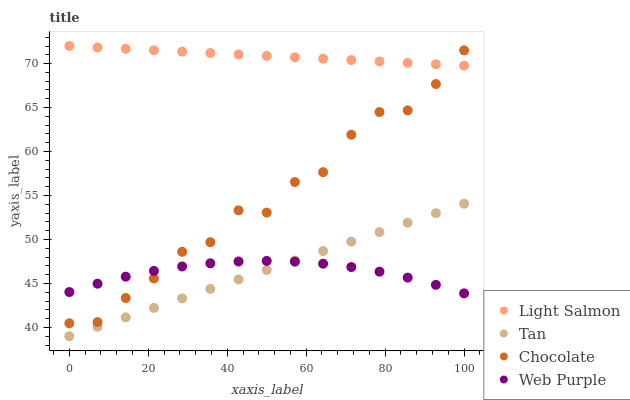Does Web Purple have the minimum area under the curve?
Answer yes or no. Yes. Does Light Salmon have the maximum area under the curve?
Answer yes or no. Yes. Does Tan have the minimum area under the curve?
Answer yes or no. No. Does Tan have the maximum area under the curve?
Answer yes or no. No. Is Tan the smoothest?
Answer yes or no. Yes. Is Chocolate the roughest?
Answer yes or no. Yes. Is Light Salmon the smoothest?
Answer yes or no. No. Is Light Salmon the roughest?
Answer yes or no. No. Does Tan have the lowest value?
Answer yes or no. Yes. Does Light Salmon have the lowest value?
Answer yes or no. No. Does Light Salmon have the highest value?
Answer yes or no. Yes. Does Tan have the highest value?
Answer yes or no. No. Is Tan less than Chocolate?
Answer yes or no. Yes. Is Chocolate greater than Tan?
Answer yes or no. Yes. Does Tan intersect Web Purple?
Answer yes or no. Yes. Is Tan less than Web Purple?
Answer yes or no. No. Is Tan greater than Web Purple?
Answer yes or no. No. Does Tan intersect Chocolate?
Answer yes or no. No. 